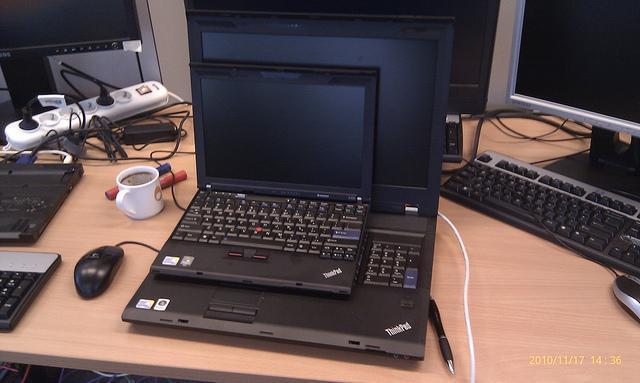How many keyboards are there?
Give a very brief answer. 2. How many tvs are there?
Give a very brief answer. 2. How many laptops are visible?
Give a very brief answer. 2. How many people are wearing a catchers helmet in the image?
Give a very brief answer. 0. 